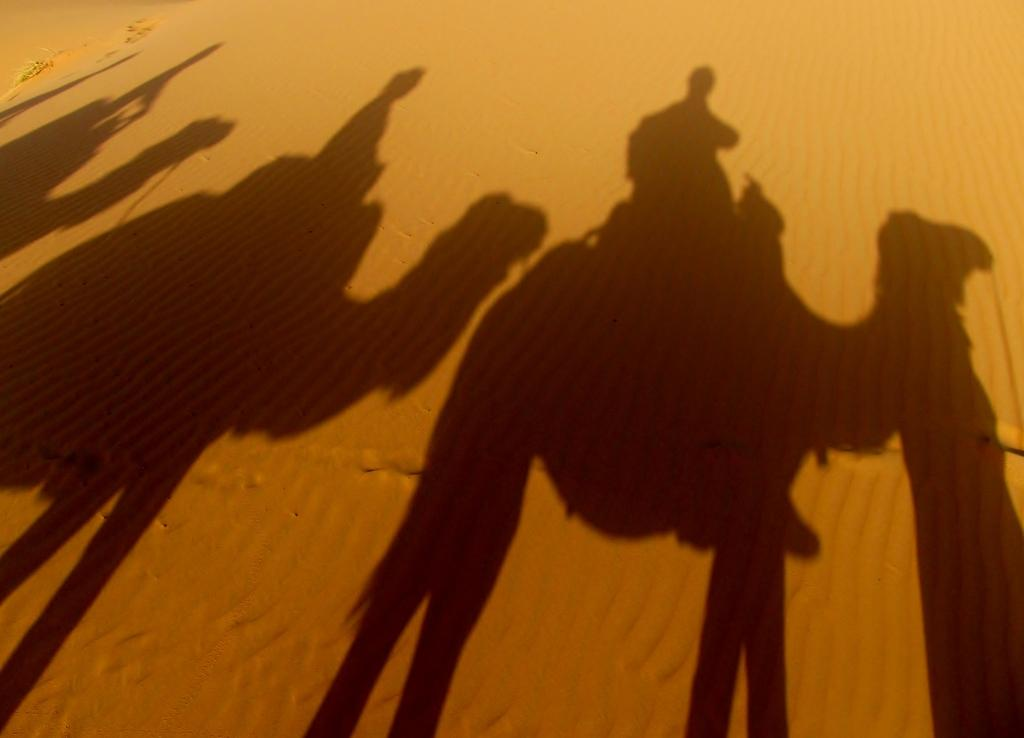What type of environment is shown in the image? The image depicts a desert. What living beings can be seen in the desert? There are people and camels in the desert. How does the environment affect the appearance of the people and camels? The people and camels are reflected on the sand, which is a characteristic of desert environments. What type of stomach ailment is affecting the camels in the image? There is no indication of any stomach ailments affecting the camels in the image. Is there a competition taking place between the people and camels in the image? The image does not depict any competition between the people and camels. 